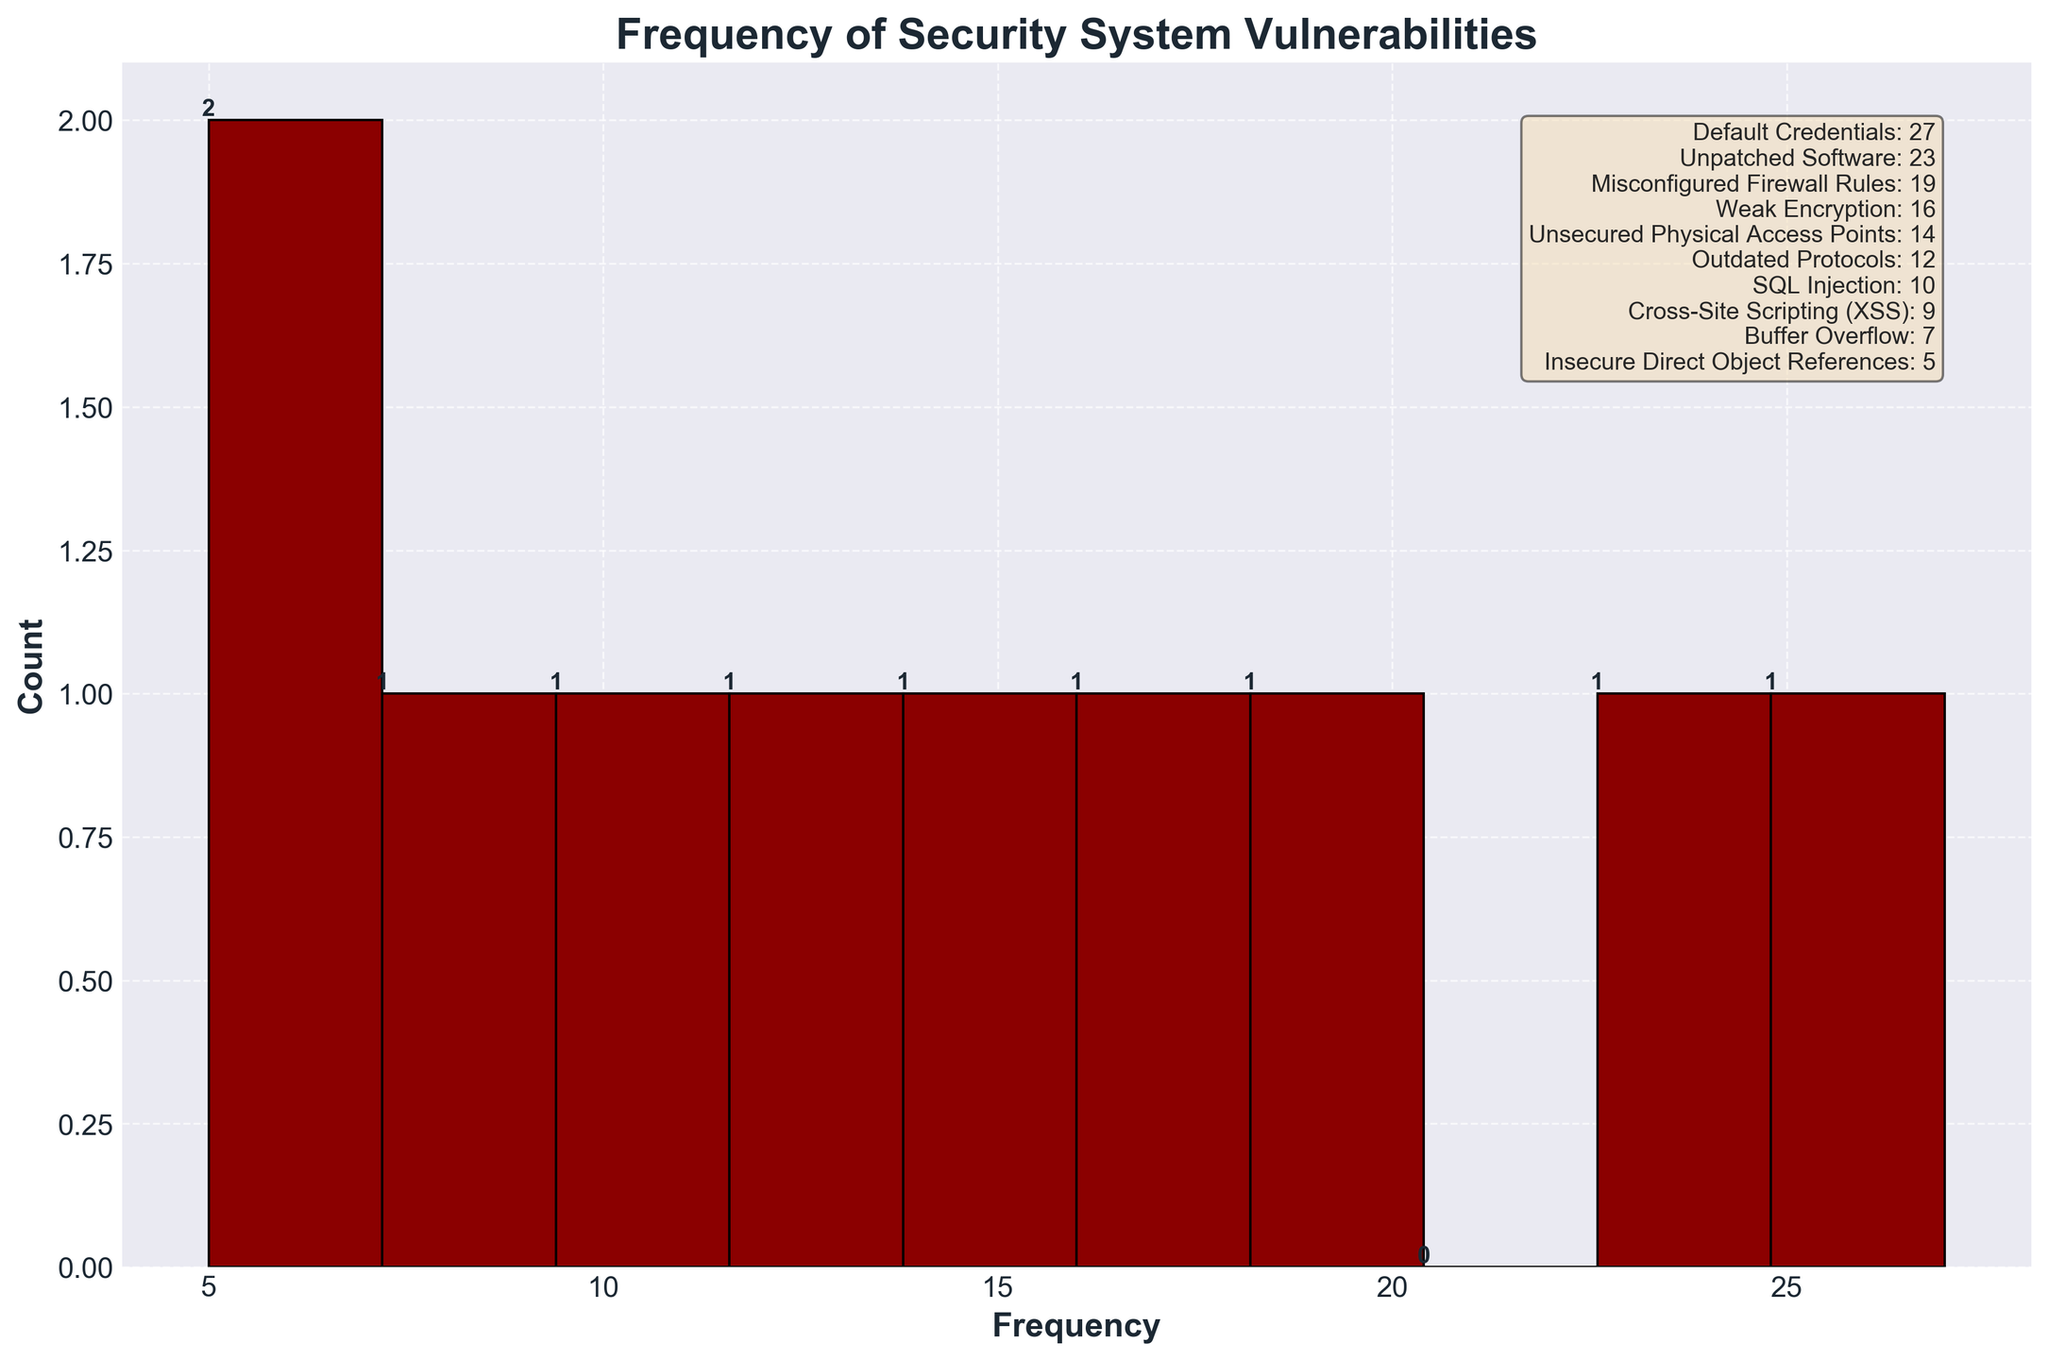What is the title of the histogram? The title is written at the top of the histogram in bold, larger font size. It reads 'Frequency of Security System Vulnerabilities'.
Answer: Frequency of Security System Vulnerabilities Which vulnerability type has the highest frequency? The highest bar corresponds to the vulnerability with the highest frequency, which is 'Default Credentials' with a frequency of 27.
Answer: Default Credentials How many vulnerability types have a frequency greater than 20? We check the bars on the histogram and count those that exceed the 20 mark, which are 'Default Credentials' (27) and 'Unpatched Software' (23).
Answer: 2 What's the least frequent vulnerability type listed? By identifying the shortest bar, which corresponds to 'Insecure Direct Object References' with a frequency of 5.
Answer: Insecure Direct Object References What range of frequencies is represented on the x-axis? The x-axis represents frequency ranges from 0 to more than 25, evidenced by the bars within those ranges on the histogram.
Answer: 0-30 Which vulnerability type has a frequency between 10 and 15? We look for bars in the histogram that falls within the 10 to 15 frequency range. 'Unsecured Physical Access Points' (14) and 'Outdated Protocols' (12) fit this range.
Answer: Unsecured Physical Access Points, Outdated Protocols How many vulnerability types have less than 10 occurrences? We count the bars with frequencies less than 10: 'Cross-Site Scripting (XSS)' (9), 'Buffer Overflow' (7), and 'Insecure Direct Object References' (5).
Answer: 3 Which vulnerability types have frequencies closer to the average frequency? First, calculate the average frequency from the data [(27+23+19+16+14+12+10+9+7+5)/10 = 14.2]. Then identify 'Unsecured Physical Access Points' (14) and 'Weak Encryption' (16) which are closest to 14.2.
Answer: Unsecured Physical Access Points, Weak Encryption What is the frequency difference between 'SQL Injection' and 'Cross-Site Scripting (XSS)'? 'SQL Injection' has a frequency of 10, and 'Cross-Site Scripting (XSS)' has a frequency of 9. The difference is 10 - 9 = 1.
Answer: 1 Which frequency has the most data points in the histogram? The histogram shows the count of each frequency. The frequency of 10 appears most frequently since it's the mode of the dataset.
Answer: 10 